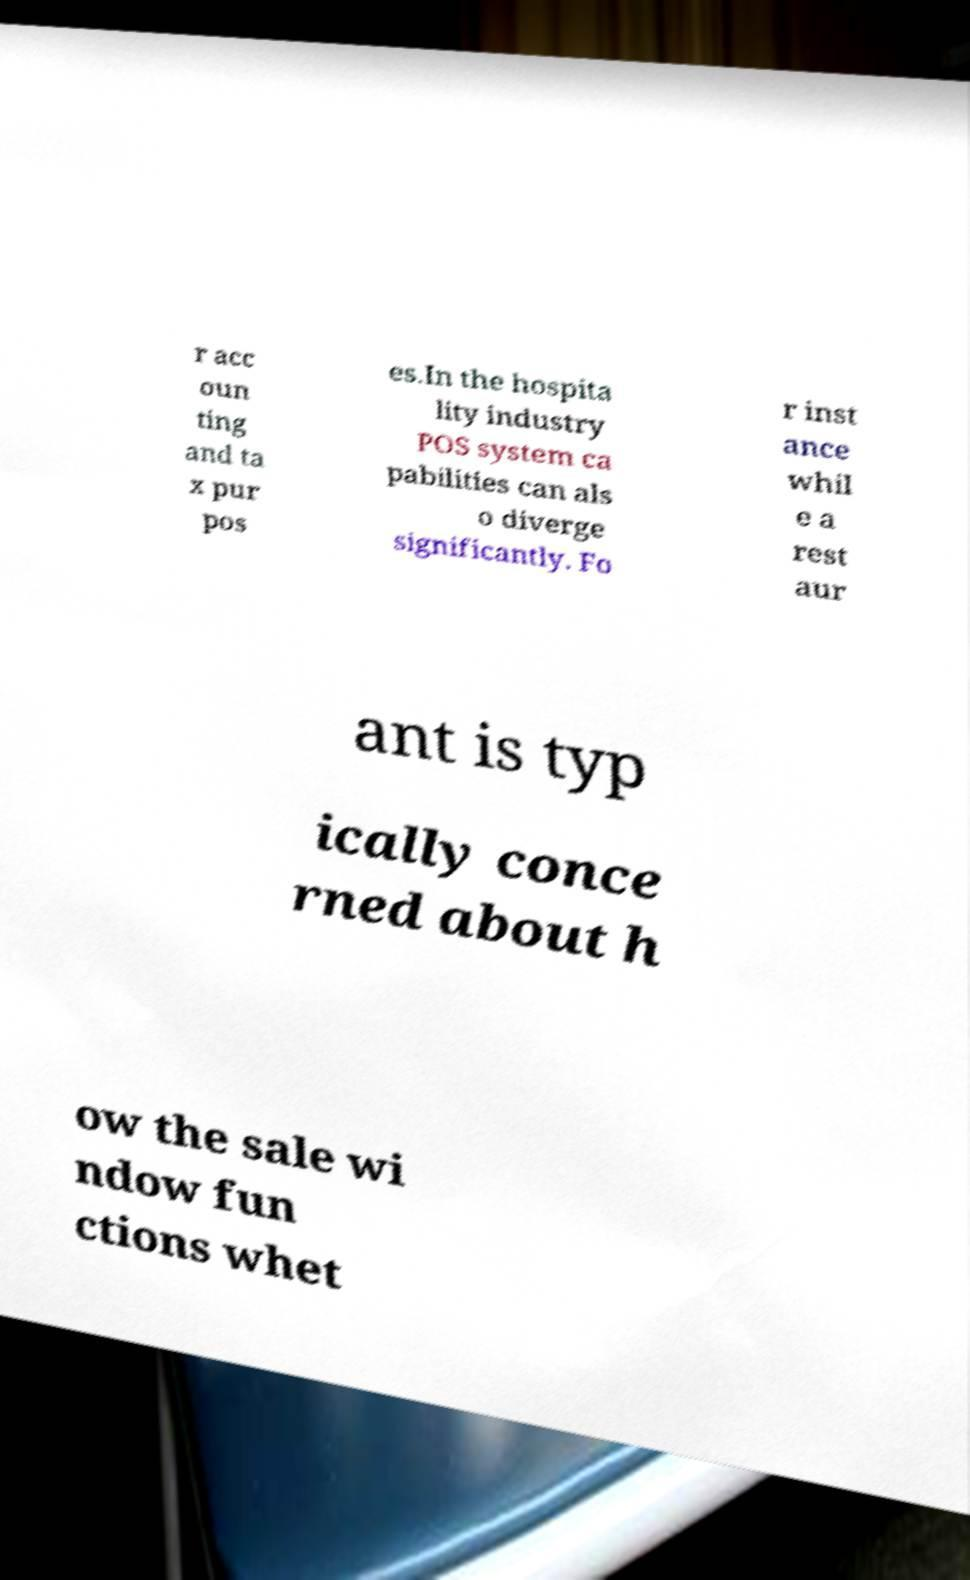For documentation purposes, I need the text within this image transcribed. Could you provide that? r acc oun ting and ta x pur pos es.In the hospita lity industry POS system ca pabilities can als o diverge significantly. Fo r inst ance whil e a rest aur ant is typ ically conce rned about h ow the sale wi ndow fun ctions whet 